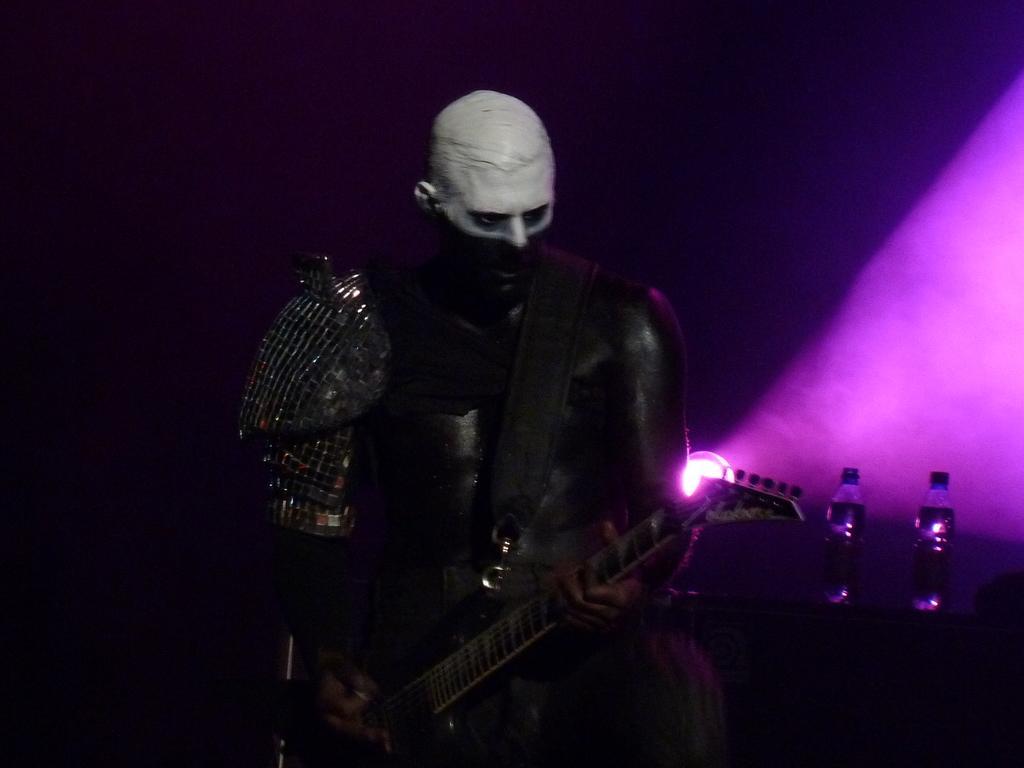Please provide a concise description of this image. A man is playing a guitar on a stage. 